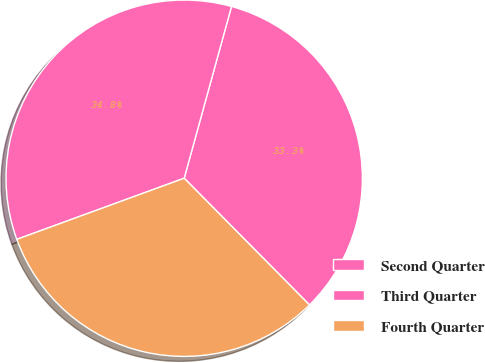Convert chart to OTSL. <chart><loc_0><loc_0><loc_500><loc_500><pie_chart><fcel>Second Quarter<fcel>Third Quarter<fcel>Fourth Quarter<nl><fcel>33.31%<fcel>34.85%<fcel>31.84%<nl></chart> 